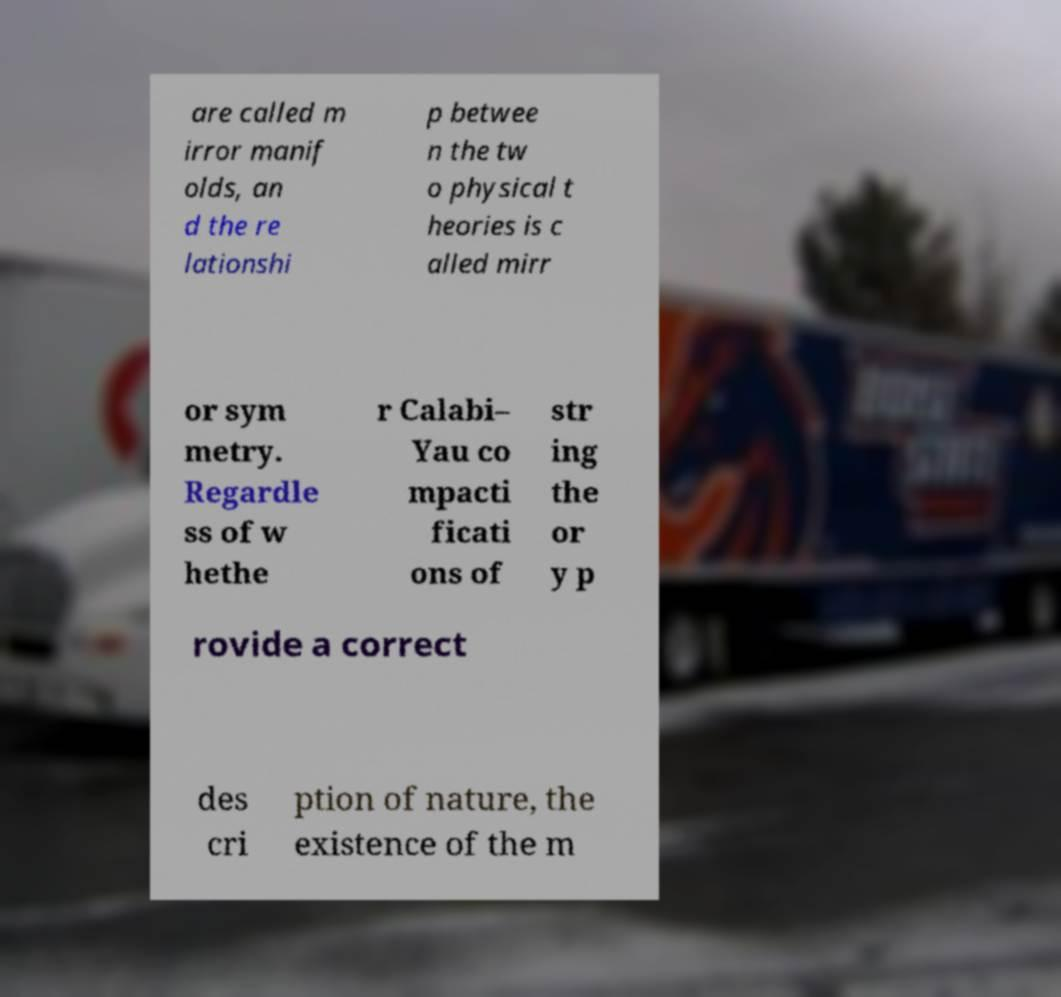Please read and relay the text visible in this image. What does it say? are called m irror manif olds, an d the re lationshi p betwee n the tw o physical t heories is c alled mirr or sym metry. Regardle ss of w hethe r Calabi– Yau co mpacti ficati ons of str ing the or y p rovide a correct des cri ption of nature, the existence of the m 